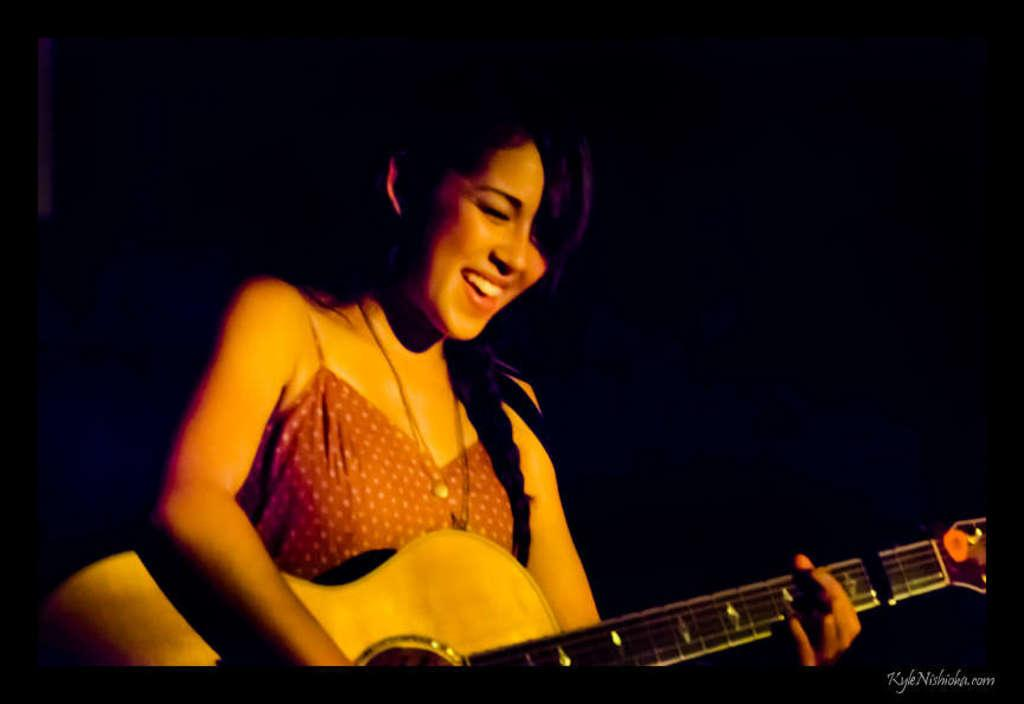Who is the main subject in the image? There is a woman in the image. What is the woman doing in the image? The woman is standing and smiling. What is the woman holding in her hand? The woman is holding a guitar in her hand. What type of books can be seen in the woman's hands in the image? There are no books present in the image; the woman is holding a guitar. How does the woman pull a donkey in the image? There is no donkey present in the image, and the woman is not pulling anything. 